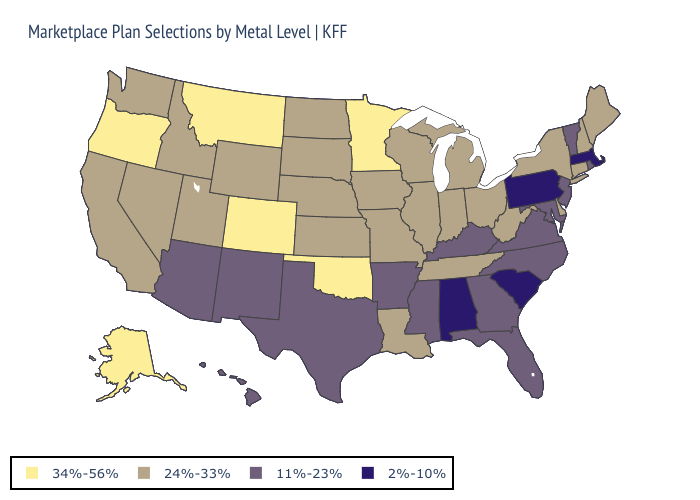Name the states that have a value in the range 24%-33%?
Quick response, please. California, Connecticut, Delaware, Idaho, Illinois, Indiana, Iowa, Kansas, Louisiana, Maine, Michigan, Missouri, Nebraska, Nevada, New Hampshire, New York, North Dakota, Ohio, South Dakota, Tennessee, Utah, Washington, West Virginia, Wisconsin, Wyoming. Name the states that have a value in the range 11%-23%?
Short answer required. Arizona, Arkansas, Florida, Georgia, Hawaii, Kentucky, Maryland, Mississippi, New Jersey, New Mexico, North Carolina, Rhode Island, Texas, Vermont, Virginia. What is the highest value in states that border Idaho?
Give a very brief answer. 34%-56%. What is the highest value in the USA?
Answer briefly. 34%-56%. Name the states that have a value in the range 11%-23%?
Concise answer only. Arizona, Arkansas, Florida, Georgia, Hawaii, Kentucky, Maryland, Mississippi, New Jersey, New Mexico, North Carolina, Rhode Island, Texas, Vermont, Virginia. What is the highest value in the USA?
Give a very brief answer. 34%-56%. Does Maine have the lowest value in the USA?
Short answer required. No. What is the lowest value in the MidWest?
Answer briefly. 24%-33%. Name the states that have a value in the range 11%-23%?
Write a very short answer. Arizona, Arkansas, Florida, Georgia, Hawaii, Kentucky, Maryland, Mississippi, New Jersey, New Mexico, North Carolina, Rhode Island, Texas, Vermont, Virginia. Name the states that have a value in the range 24%-33%?
Quick response, please. California, Connecticut, Delaware, Idaho, Illinois, Indiana, Iowa, Kansas, Louisiana, Maine, Michigan, Missouri, Nebraska, Nevada, New Hampshire, New York, North Dakota, Ohio, South Dakota, Tennessee, Utah, Washington, West Virginia, Wisconsin, Wyoming. Does Vermont have a lower value than North Carolina?
Answer briefly. No. Does South Carolina have the lowest value in the USA?
Short answer required. Yes. What is the value of Colorado?
Short answer required. 34%-56%. Does the map have missing data?
Be succinct. No. Is the legend a continuous bar?
Give a very brief answer. No. 